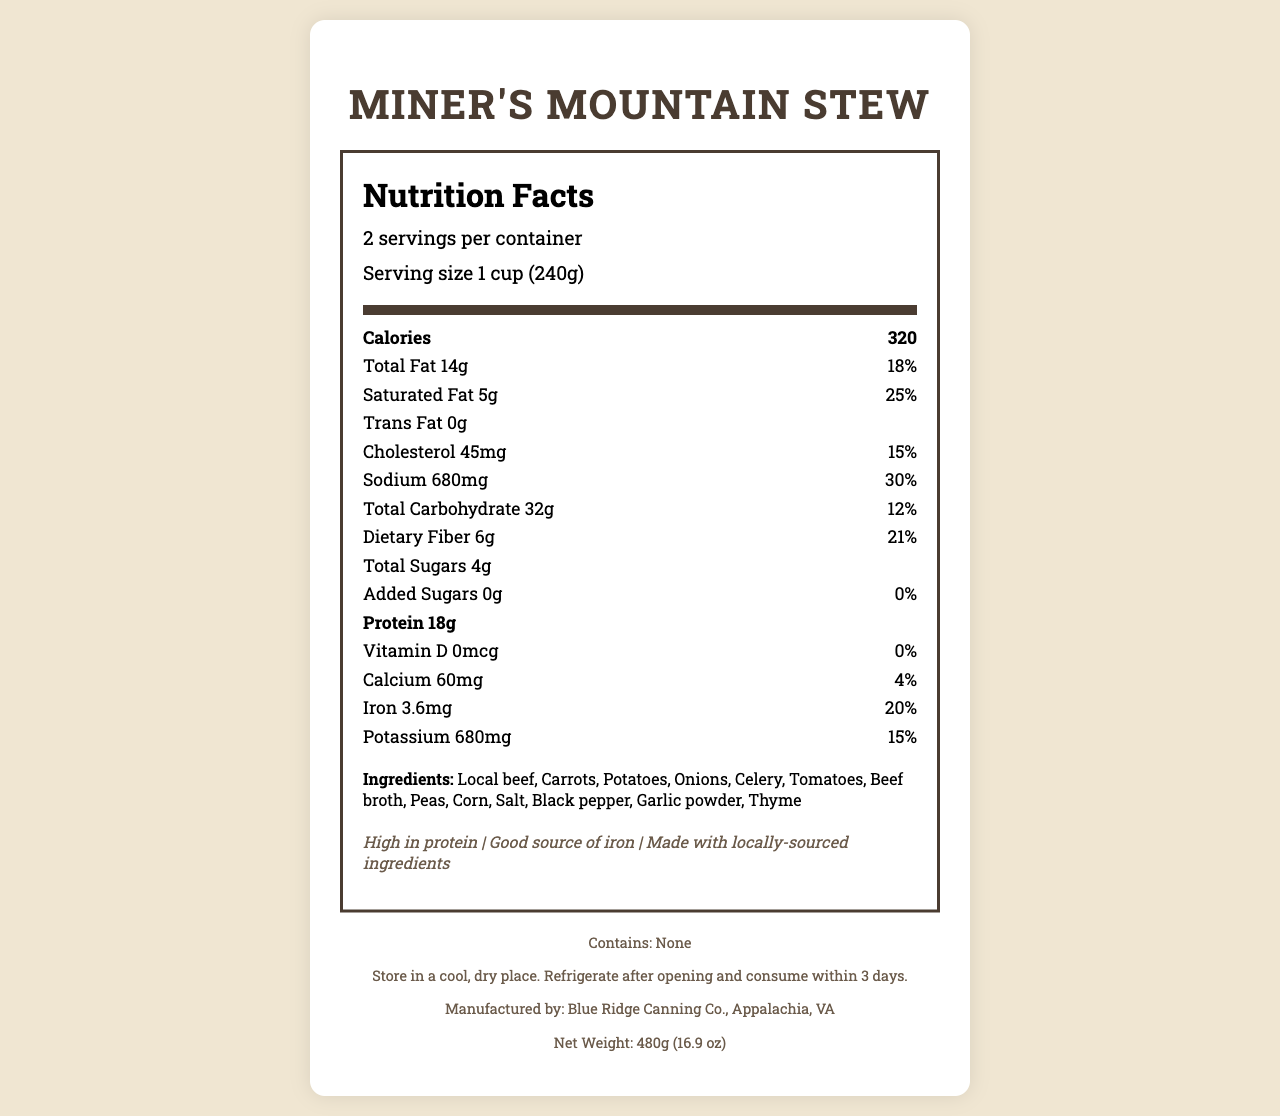what is the serving size? The serving size is explicitly mentioned in the document under the serving information section.
Answer: 1 cup (240g) how many calories are in one serving? The document lists the number of calories per serving as 320.
Answer: 320 how many servings are in a container? The number of servings per container is listed as 2.
Answer: 2 what is the percentage of daily value for saturated fat in one serving? The percentage of daily value for saturated fat is given as 25%.
Answer: 25% which ingredient comes first in the list? The ingredient list is ordered, with Local beef being the first item.
Answer: Local beef what is the amount of protein per serving? The amount of protein per serving is listed as 18g.
Answer: 18g how much iron is in one serving? The document specifies that each serving contains 3.6mg of iron.
Answer: 3.6mg what is the daily value percentage of dietary fiber in one serving? The daily value percentage for dietary fiber in one serving is 21%.
Answer: 21% are there any trans fats in the stew? The Trans Fat value is listed as 0g, indicating there are no trans fats.
Answer: No how much sodium is in one serving? The document shows that one serving contains 680mg of sodium.
Answer: 680mg how many total sugars are in one serving? The total amount of sugars per serving is 4g.
Answer: 4g what is the storage instruction for the stew? The storage instructions are clearly stated at the bottom of the document.
Answer: Store in a cool, dry place. Refrigerate after opening and consume within 3 days. who is the manufacturer of Miner's Mountain Stew? The manufacturer information is listed at the bottom of the document.
Answer: Blue Ridge Canning Co., Appalachia, VA what is the net weight of the container? The net weight is indicated at the bottom of the document as 480g (16.9 oz).
Answer: 480g (16.9 oz) what is the daily value percentage for calcium? The daily value percentage for calcium is shown as 4%.
Answer: 4% what percentage of the daily value for sodium does one serving provide? A. 15% B. 10% C. 30% The daily value percentage for sodium given is 30%.
Answer: C. 30% which of the following is not an ingredient in Miner's Mountain Stew: A. Onions B. Peas C. Cabbage The ingredient list includes Onions and Peas, but not Cabbage.
Answer: C. Cabbage does the stew contain any allergen information? The allergen information is clearly stated as "Contains: None."
Answer: No what claims are made about the stew? The claims section lists these three claims about the stew.
Answer: High in protein, Good source of iron, Made with locally-sourced ingredients what is the main idea of the document? The document is focused on delivering comprehensive nutritional information along with other relevant details about Miner's Mountain Stew.
Answer: The document provides detailed nutrition facts, ingredients, storage instructions, and manufacturer information for Miner's Mountain Stew. what is the recommended daily intake of sodium for an average adult? The document does not provide any information about the recommended daily intake of sodium for an average adult.
Answer: Not enough information what vitamin is missing from Miner's Mountain Stew? The document shows that Vitamin D is listed as 0mcg, indicating it is missing.
Answer: Vitamin D 